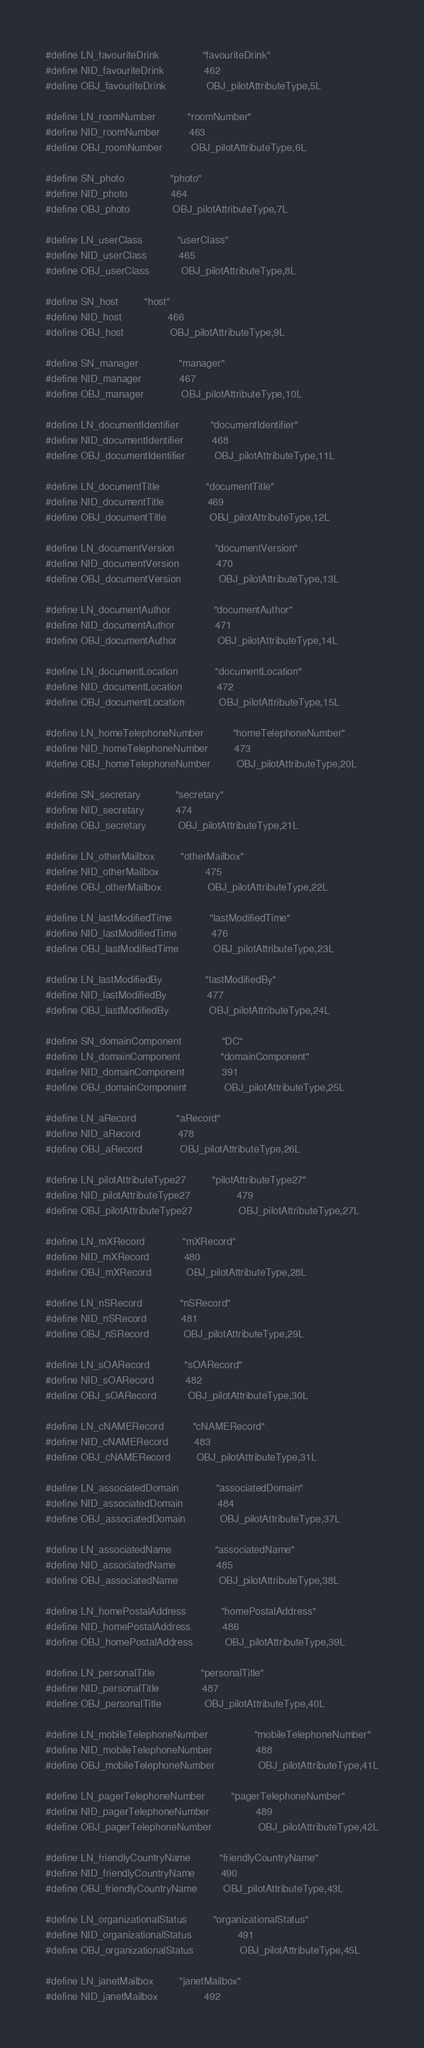Convert code to text. <code><loc_0><loc_0><loc_500><loc_500><_C_>
#define LN_favouriteDrink               "favouriteDrink"
#define NID_favouriteDrink              462
#define OBJ_favouriteDrink              OBJ_pilotAttributeType,5L

#define LN_roomNumber           "roomNumber"
#define NID_roomNumber          463
#define OBJ_roomNumber          OBJ_pilotAttributeType,6L

#define SN_photo                "photo"
#define NID_photo               464
#define OBJ_photo               OBJ_pilotAttributeType,7L

#define LN_userClass            "userClass"
#define NID_userClass           465
#define OBJ_userClass           OBJ_pilotAttributeType,8L

#define SN_host         "host"
#define NID_host                466
#define OBJ_host                OBJ_pilotAttributeType,9L

#define SN_manager              "manager"
#define NID_manager             467
#define OBJ_manager             OBJ_pilotAttributeType,10L

#define LN_documentIdentifier           "documentIdentifier"
#define NID_documentIdentifier          468
#define OBJ_documentIdentifier          OBJ_pilotAttributeType,11L

#define LN_documentTitle                "documentTitle"
#define NID_documentTitle               469
#define OBJ_documentTitle               OBJ_pilotAttributeType,12L

#define LN_documentVersion              "documentVersion"
#define NID_documentVersion             470
#define OBJ_documentVersion             OBJ_pilotAttributeType,13L

#define LN_documentAuthor               "documentAuthor"
#define NID_documentAuthor              471
#define OBJ_documentAuthor              OBJ_pilotAttributeType,14L

#define LN_documentLocation             "documentLocation"
#define NID_documentLocation            472
#define OBJ_documentLocation            OBJ_pilotAttributeType,15L

#define LN_homeTelephoneNumber          "homeTelephoneNumber"
#define NID_homeTelephoneNumber         473
#define OBJ_homeTelephoneNumber         OBJ_pilotAttributeType,20L

#define SN_secretary            "secretary"
#define NID_secretary           474
#define OBJ_secretary           OBJ_pilotAttributeType,21L

#define LN_otherMailbox         "otherMailbox"
#define NID_otherMailbox                475
#define OBJ_otherMailbox                OBJ_pilotAttributeType,22L

#define LN_lastModifiedTime             "lastModifiedTime"
#define NID_lastModifiedTime            476
#define OBJ_lastModifiedTime            OBJ_pilotAttributeType,23L

#define LN_lastModifiedBy               "lastModifiedBy"
#define NID_lastModifiedBy              477
#define OBJ_lastModifiedBy              OBJ_pilotAttributeType,24L

#define SN_domainComponent              "DC"
#define LN_domainComponent              "domainComponent"
#define NID_domainComponent             391
#define OBJ_domainComponent             OBJ_pilotAttributeType,25L

#define LN_aRecord              "aRecord"
#define NID_aRecord             478
#define OBJ_aRecord             OBJ_pilotAttributeType,26L

#define LN_pilotAttributeType27         "pilotAttributeType27"
#define NID_pilotAttributeType27                479
#define OBJ_pilotAttributeType27                OBJ_pilotAttributeType,27L

#define LN_mXRecord             "mXRecord"
#define NID_mXRecord            480
#define OBJ_mXRecord            OBJ_pilotAttributeType,28L

#define LN_nSRecord             "nSRecord"
#define NID_nSRecord            481
#define OBJ_nSRecord            OBJ_pilotAttributeType,29L

#define LN_sOARecord            "sOARecord"
#define NID_sOARecord           482
#define OBJ_sOARecord           OBJ_pilotAttributeType,30L

#define LN_cNAMERecord          "cNAMERecord"
#define NID_cNAMERecord         483
#define OBJ_cNAMERecord         OBJ_pilotAttributeType,31L

#define LN_associatedDomain             "associatedDomain"
#define NID_associatedDomain            484
#define OBJ_associatedDomain            OBJ_pilotAttributeType,37L

#define LN_associatedName               "associatedName"
#define NID_associatedName              485
#define OBJ_associatedName              OBJ_pilotAttributeType,38L

#define LN_homePostalAddress            "homePostalAddress"
#define NID_homePostalAddress           486
#define OBJ_homePostalAddress           OBJ_pilotAttributeType,39L

#define LN_personalTitle                "personalTitle"
#define NID_personalTitle               487
#define OBJ_personalTitle               OBJ_pilotAttributeType,40L

#define LN_mobileTelephoneNumber                "mobileTelephoneNumber"
#define NID_mobileTelephoneNumber               488
#define OBJ_mobileTelephoneNumber               OBJ_pilotAttributeType,41L

#define LN_pagerTelephoneNumber         "pagerTelephoneNumber"
#define NID_pagerTelephoneNumber                489
#define OBJ_pagerTelephoneNumber                OBJ_pilotAttributeType,42L

#define LN_friendlyCountryName          "friendlyCountryName"
#define NID_friendlyCountryName         490
#define OBJ_friendlyCountryName         OBJ_pilotAttributeType,43L

#define LN_organizationalStatus         "organizationalStatus"
#define NID_organizationalStatus                491
#define OBJ_organizationalStatus                OBJ_pilotAttributeType,45L

#define LN_janetMailbox         "janetMailbox"
#define NID_janetMailbox                492</code> 